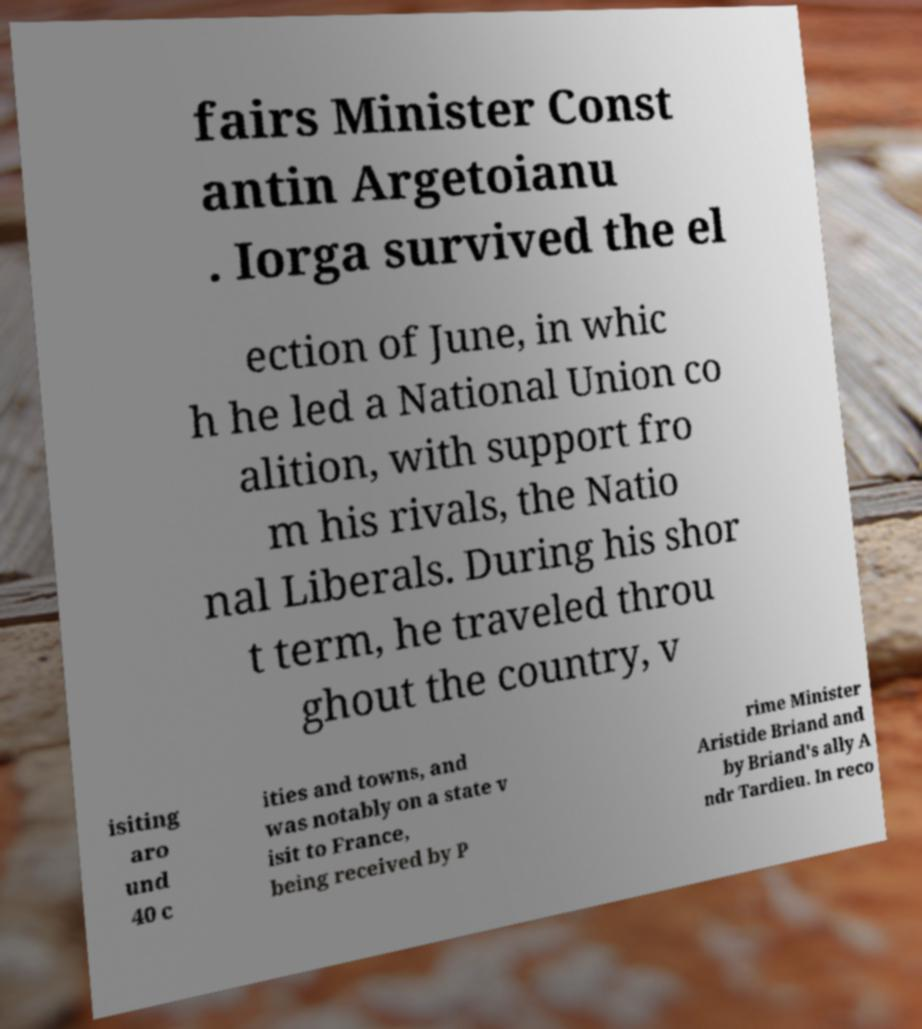There's text embedded in this image that I need extracted. Can you transcribe it verbatim? fairs Minister Const antin Argetoianu . Iorga survived the el ection of June, in whic h he led a National Union co alition, with support fro m his rivals, the Natio nal Liberals. During his shor t term, he traveled throu ghout the country, v isiting aro und 40 c ities and towns, and was notably on a state v isit to France, being received by P rime Minister Aristide Briand and by Briand's ally A ndr Tardieu. In reco 